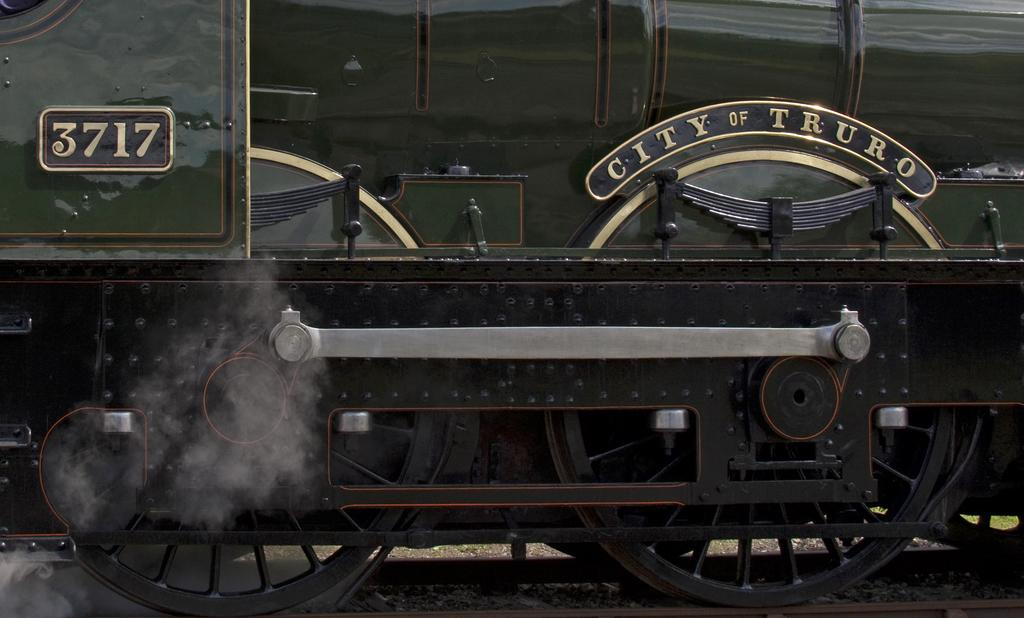What is the main subject of the image? The main subject of the image is a train. Where is the train located in the image? The train is on a track. What type of cloth is draped over the train in the image? There is no cloth draped over the train in the image. What prose can be read on the side of the train in the image? There is no prose visible on the train in the image. 